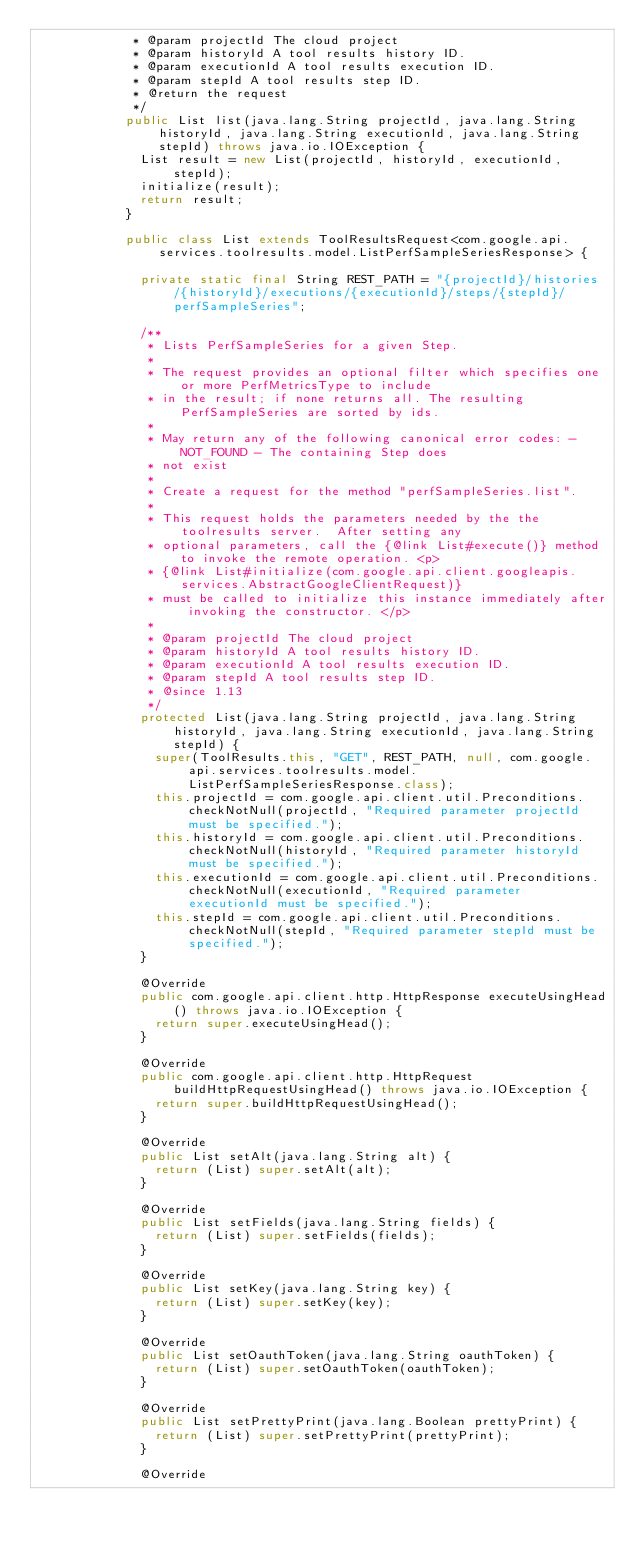<code> <loc_0><loc_0><loc_500><loc_500><_Java_>             * @param projectId The cloud project
             * @param historyId A tool results history ID.
             * @param executionId A tool results execution ID.
             * @param stepId A tool results step ID.
             * @return the request
             */
            public List list(java.lang.String projectId, java.lang.String historyId, java.lang.String executionId, java.lang.String stepId) throws java.io.IOException {
              List result = new List(projectId, historyId, executionId, stepId);
              initialize(result);
              return result;
            }

            public class List extends ToolResultsRequest<com.google.api.services.toolresults.model.ListPerfSampleSeriesResponse> {

              private static final String REST_PATH = "{projectId}/histories/{historyId}/executions/{executionId}/steps/{stepId}/perfSampleSeries";

              /**
               * Lists PerfSampleSeries for a given Step.
               *
               * The request provides an optional filter which specifies one or more PerfMetricsType to include
               * in the result; if none returns all. The resulting PerfSampleSeries are sorted by ids.
               *
               * May return any of the following canonical error codes: - NOT_FOUND - The containing Step does
               * not exist
               *
               * Create a request for the method "perfSampleSeries.list".
               *
               * This request holds the parameters needed by the the toolresults server.  After setting any
               * optional parameters, call the {@link List#execute()} method to invoke the remote operation. <p>
               * {@link List#initialize(com.google.api.client.googleapis.services.AbstractGoogleClientRequest)}
               * must be called to initialize this instance immediately after invoking the constructor. </p>
               *
               * @param projectId The cloud project
               * @param historyId A tool results history ID.
               * @param executionId A tool results execution ID.
               * @param stepId A tool results step ID.
               * @since 1.13
               */
              protected List(java.lang.String projectId, java.lang.String historyId, java.lang.String executionId, java.lang.String stepId) {
                super(ToolResults.this, "GET", REST_PATH, null, com.google.api.services.toolresults.model.ListPerfSampleSeriesResponse.class);
                this.projectId = com.google.api.client.util.Preconditions.checkNotNull(projectId, "Required parameter projectId must be specified.");
                this.historyId = com.google.api.client.util.Preconditions.checkNotNull(historyId, "Required parameter historyId must be specified.");
                this.executionId = com.google.api.client.util.Preconditions.checkNotNull(executionId, "Required parameter executionId must be specified.");
                this.stepId = com.google.api.client.util.Preconditions.checkNotNull(stepId, "Required parameter stepId must be specified.");
              }

              @Override
              public com.google.api.client.http.HttpResponse executeUsingHead() throws java.io.IOException {
                return super.executeUsingHead();
              }

              @Override
              public com.google.api.client.http.HttpRequest buildHttpRequestUsingHead() throws java.io.IOException {
                return super.buildHttpRequestUsingHead();
              }

              @Override
              public List setAlt(java.lang.String alt) {
                return (List) super.setAlt(alt);
              }

              @Override
              public List setFields(java.lang.String fields) {
                return (List) super.setFields(fields);
              }

              @Override
              public List setKey(java.lang.String key) {
                return (List) super.setKey(key);
              }

              @Override
              public List setOauthToken(java.lang.String oauthToken) {
                return (List) super.setOauthToken(oauthToken);
              }

              @Override
              public List setPrettyPrint(java.lang.Boolean prettyPrint) {
                return (List) super.setPrettyPrint(prettyPrint);
              }

              @Override</code> 